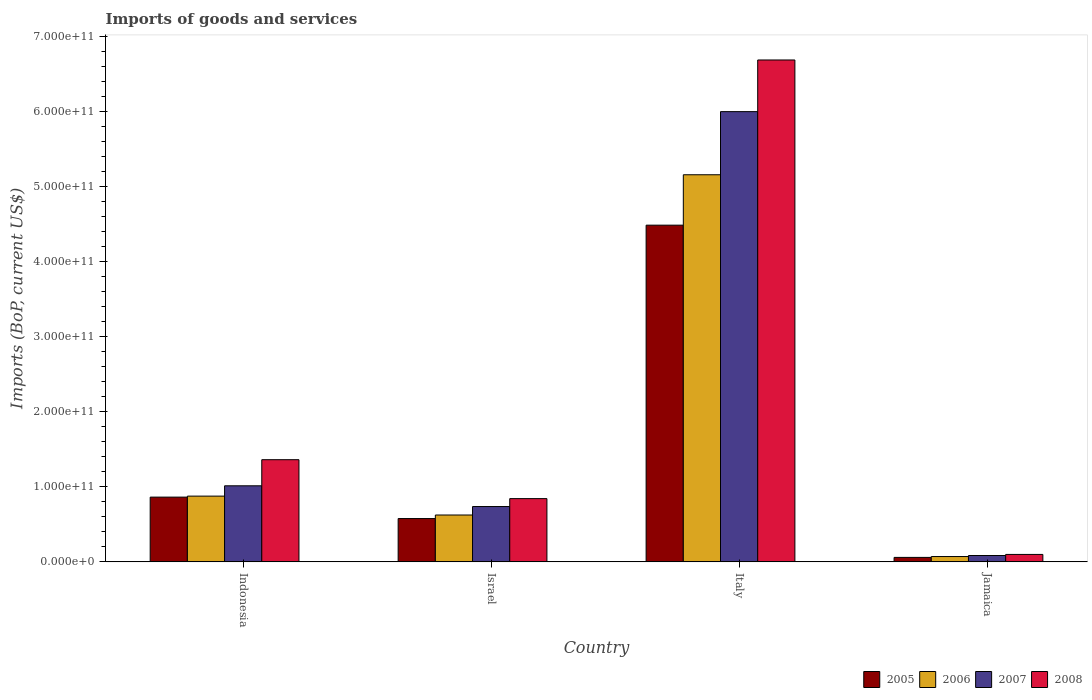How many different coloured bars are there?
Offer a terse response. 4. Are the number of bars per tick equal to the number of legend labels?
Your answer should be compact. Yes. How many bars are there on the 1st tick from the right?
Offer a terse response. 4. What is the label of the 4th group of bars from the left?
Ensure brevity in your answer.  Jamaica. In how many cases, is the number of bars for a given country not equal to the number of legend labels?
Make the answer very short. 0. What is the amount spent on imports in 2006 in Italy?
Offer a very short reply. 5.16e+11. Across all countries, what is the maximum amount spent on imports in 2005?
Give a very brief answer. 4.49e+11. Across all countries, what is the minimum amount spent on imports in 2007?
Keep it short and to the point. 8.49e+09. In which country was the amount spent on imports in 2005 maximum?
Keep it short and to the point. Italy. In which country was the amount spent on imports in 2007 minimum?
Offer a terse response. Jamaica. What is the total amount spent on imports in 2006 in the graph?
Offer a very short reply. 6.73e+11. What is the difference between the amount spent on imports in 2006 in Israel and that in Jamaica?
Provide a short and direct response. 5.53e+1. What is the difference between the amount spent on imports in 2008 in Israel and the amount spent on imports in 2006 in Jamaica?
Keep it short and to the point. 7.72e+1. What is the average amount spent on imports in 2006 per country?
Keep it short and to the point. 1.68e+11. What is the difference between the amount spent on imports of/in 2005 and amount spent on imports of/in 2006 in Jamaica?
Provide a short and direct response. -1.13e+09. In how many countries, is the amount spent on imports in 2008 greater than 620000000000 US$?
Your response must be concise. 1. What is the ratio of the amount spent on imports in 2008 in Indonesia to that in Jamaica?
Make the answer very short. 13.73. Is the amount spent on imports in 2006 in Indonesia less than that in Italy?
Ensure brevity in your answer.  Yes. What is the difference between the highest and the second highest amount spent on imports in 2006?
Your answer should be compact. 4.53e+11. What is the difference between the highest and the lowest amount spent on imports in 2005?
Make the answer very short. 4.43e+11. In how many countries, is the amount spent on imports in 2005 greater than the average amount spent on imports in 2005 taken over all countries?
Make the answer very short. 1. Is the sum of the amount spent on imports in 2005 in Indonesia and Italy greater than the maximum amount spent on imports in 2007 across all countries?
Ensure brevity in your answer.  No. How many bars are there?
Offer a very short reply. 16. How many countries are there in the graph?
Your answer should be compact. 4. What is the difference between two consecutive major ticks on the Y-axis?
Make the answer very short. 1.00e+11. Are the values on the major ticks of Y-axis written in scientific E-notation?
Make the answer very short. Yes. Where does the legend appear in the graph?
Your answer should be very brief. Bottom right. How many legend labels are there?
Your answer should be very brief. 4. How are the legend labels stacked?
Your answer should be very brief. Horizontal. What is the title of the graph?
Keep it short and to the point. Imports of goods and services. What is the label or title of the Y-axis?
Provide a short and direct response. Imports (BoP, current US$). What is the Imports (BoP, current US$) of 2005 in Indonesia?
Ensure brevity in your answer.  8.63e+1. What is the Imports (BoP, current US$) of 2006 in Indonesia?
Keep it short and to the point. 8.76e+1. What is the Imports (BoP, current US$) of 2007 in Indonesia?
Your response must be concise. 1.01e+11. What is the Imports (BoP, current US$) of 2008 in Indonesia?
Offer a very short reply. 1.36e+11. What is the Imports (BoP, current US$) in 2005 in Israel?
Provide a succinct answer. 5.77e+1. What is the Imports (BoP, current US$) in 2006 in Israel?
Provide a short and direct response. 6.24e+1. What is the Imports (BoP, current US$) in 2007 in Israel?
Your response must be concise. 7.37e+1. What is the Imports (BoP, current US$) of 2008 in Israel?
Give a very brief answer. 8.43e+1. What is the Imports (BoP, current US$) in 2005 in Italy?
Give a very brief answer. 4.49e+11. What is the Imports (BoP, current US$) of 2006 in Italy?
Your answer should be very brief. 5.16e+11. What is the Imports (BoP, current US$) of 2007 in Italy?
Keep it short and to the point. 6.00e+11. What is the Imports (BoP, current US$) of 2008 in Italy?
Make the answer very short. 6.69e+11. What is the Imports (BoP, current US$) in 2005 in Jamaica?
Make the answer very short. 5.97e+09. What is the Imports (BoP, current US$) of 2006 in Jamaica?
Provide a short and direct response. 7.10e+09. What is the Imports (BoP, current US$) in 2007 in Jamaica?
Your answer should be very brief. 8.49e+09. What is the Imports (BoP, current US$) in 2008 in Jamaica?
Keep it short and to the point. 9.91e+09. Across all countries, what is the maximum Imports (BoP, current US$) in 2005?
Provide a short and direct response. 4.49e+11. Across all countries, what is the maximum Imports (BoP, current US$) of 2006?
Your answer should be compact. 5.16e+11. Across all countries, what is the maximum Imports (BoP, current US$) in 2007?
Give a very brief answer. 6.00e+11. Across all countries, what is the maximum Imports (BoP, current US$) in 2008?
Keep it short and to the point. 6.69e+11. Across all countries, what is the minimum Imports (BoP, current US$) of 2005?
Keep it short and to the point. 5.97e+09. Across all countries, what is the minimum Imports (BoP, current US$) in 2006?
Keep it short and to the point. 7.10e+09. Across all countries, what is the minimum Imports (BoP, current US$) of 2007?
Keep it short and to the point. 8.49e+09. Across all countries, what is the minimum Imports (BoP, current US$) in 2008?
Provide a short and direct response. 9.91e+09. What is the total Imports (BoP, current US$) of 2005 in the graph?
Your response must be concise. 5.99e+11. What is the total Imports (BoP, current US$) of 2006 in the graph?
Ensure brevity in your answer.  6.73e+11. What is the total Imports (BoP, current US$) in 2007 in the graph?
Your answer should be very brief. 7.83e+11. What is the total Imports (BoP, current US$) of 2008 in the graph?
Offer a terse response. 8.99e+11. What is the difference between the Imports (BoP, current US$) in 2005 in Indonesia and that in Israel?
Keep it short and to the point. 2.86e+1. What is the difference between the Imports (BoP, current US$) of 2006 in Indonesia and that in Israel?
Your response must be concise. 2.52e+1. What is the difference between the Imports (BoP, current US$) in 2007 in Indonesia and that in Israel?
Ensure brevity in your answer.  2.76e+1. What is the difference between the Imports (BoP, current US$) of 2008 in Indonesia and that in Israel?
Your answer should be compact. 5.19e+1. What is the difference between the Imports (BoP, current US$) in 2005 in Indonesia and that in Italy?
Keep it short and to the point. -3.62e+11. What is the difference between the Imports (BoP, current US$) of 2006 in Indonesia and that in Italy?
Ensure brevity in your answer.  -4.28e+11. What is the difference between the Imports (BoP, current US$) in 2007 in Indonesia and that in Italy?
Your answer should be very brief. -4.98e+11. What is the difference between the Imports (BoP, current US$) in 2008 in Indonesia and that in Italy?
Your answer should be compact. -5.33e+11. What is the difference between the Imports (BoP, current US$) of 2005 in Indonesia and that in Jamaica?
Offer a terse response. 8.03e+1. What is the difference between the Imports (BoP, current US$) in 2006 in Indonesia and that in Jamaica?
Ensure brevity in your answer.  8.05e+1. What is the difference between the Imports (BoP, current US$) in 2007 in Indonesia and that in Jamaica?
Offer a terse response. 9.29e+1. What is the difference between the Imports (BoP, current US$) of 2008 in Indonesia and that in Jamaica?
Your answer should be compact. 1.26e+11. What is the difference between the Imports (BoP, current US$) of 2005 in Israel and that in Italy?
Keep it short and to the point. -3.91e+11. What is the difference between the Imports (BoP, current US$) in 2006 in Israel and that in Italy?
Make the answer very short. -4.53e+11. What is the difference between the Imports (BoP, current US$) in 2007 in Israel and that in Italy?
Your answer should be compact. -5.26e+11. What is the difference between the Imports (BoP, current US$) in 2008 in Israel and that in Italy?
Offer a terse response. -5.84e+11. What is the difference between the Imports (BoP, current US$) in 2005 in Israel and that in Jamaica?
Offer a terse response. 5.17e+1. What is the difference between the Imports (BoP, current US$) of 2006 in Israel and that in Jamaica?
Give a very brief answer. 5.53e+1. What is the difference between the Imports (BoP, current US$) of 2007 in Israel and that in Jamaica?
Ensure brevity in your answer.  6.52e+1. What is the difference between the Imports (BoP, current US$) in 2008 in Israel and that in Jamaica?
Provide a short and direct response. 7.44e+1. What is the difference between the Imports (BoP, current US$) of 2005 in Italy and that in Jamaica?
Your answer should be compact. 4.43e+11. What is the difference between the Imports (BoP, current US$) in 2006 in Italy and that in Jamaica?
Keep it short and to the point. 5.09e+11. What is the difference between the Imports (BoP, current US$) in 2007 in Italy and that in Jamaica?
Your response must be concise. 5.91e+11. What is the difference between the Imports (BoP, current US$) in 2008 in Italy and that in Jamaica?
Offer a very short reply. 6.59e+11. What is the difference between the Imports (BoP, current US$) of 2005 in Indonesia and the Imports (BoP, current US$) of 2006 in Israel?
Keep it short and to the point. 2.38e+1. What is the difference between the Imports (BoP, current US$) of 2005 in Indonesia and the Imports (BoP, current US$) of 2007 in Israel?
Offer a very short reply. 1.26e+1. What is the difference between the Imports (BoP, current US$) of 2005 in Indonesia and the Imports (BoP, current US$) of 2008 in Israel?
Provide a short and direct response. 1.98e+09. What is the difference between the Imports (BoP, current US$) of 2006 in Indonesia and the Imports (BoP, current US$) of 2007 in Israel?
Give a very brief answer. 1.39e+1. What is the difference between the Imports (BoP, current US$) of 2006 in Indonesia and the Imports (BoP, current US$) of 2008 in Israel?
Your answer should be compact. 3.33e+09. What is the difference between the Imports (BoP, current US$) of 2007 in Indonesia and the Imports (BoP, current US$) of 2008 in Israel?
Your answer should be compact. 1.71e+1. What is the difference between the Imports (BoP, current US$) in 2005 in Indonesia and the Imports (BoP, current US$) in 2006 in Italy?
Provide a short and direct response. -4.29e+11. What is the difference between the Imports (BoP, current US$) in 2005 in Indonesia and the Imports (BoP, current US$) in 2007 in Italy?
Make the answer very short. -5.14e+11. What is the difference between the Imports (BoP, current US$) of 2005 in Indonesia and the Imports (BoP, current US$) of 2008 in Italy?
Provide a short and direct response. -5.82e+11. What is the difference between the Imports (BoP, current US$) in 2006 in Indonesia and the Imports (BoP, current US$) in 2007 in Italy?
Give a very brief answer. -5.12e+11. What is the difference between the Imports (BoP, current US$) of 2006 in Indonesia and the Imports (BoP, current US$) of 2008 in Italy?
Make the answer very short. -5.81e+11. What is the difference between the Imports (BoP, current US$) of 2007 in Indonesia and the Imports (BoP, current US$) of 2008 in Italy?
Your response must be concise. -5.67e+11. What is the difference between the Imports (BoP, current US$) of 2005 in Indonesia and the Imports (BoP, current US$) of 2006 in Jamaica?
Your answer should be compact. 7.92e+1. What is the difference between the Imports (BoP, current US$) of 2005 in Indonesia and the Imports (BoP, current US$) of 2007 in Jamaica?
Provide a short and direct response. 7.78e+1. What is the difference between the Imports (BoP, current US$) in 2005 in Indonesia and the Imports (BoP, current US$) in 2008 in Jamaica?
Your response must be concise. 7.64e+1. What is the difference between the Imports (BoP, current US$) in 2006 in Indonesia and the Imports (BoP, current US$) in 2007 in Jamaica?
Make the answer very short. 7.91e+1. What is the difference between the Imports (BoP, current US$) of 2006 in Indonesia and the Imports (BoP, current US$) of 2008 in Jamaica?
Provide a short and direct response. 7.77e+1. What is the difference between the Imports (BoP, current US$) of 2007 in Indonesia and the Imports (BoP, current US$) of 2008 in Jamaica?
Give a very brief answer. 9.14e+1. What is the difference between the Imports (BoP, current US$) of 2005 in Israel and the Imports (BoP, current US$) of 2006 in Italy?
Ensure brevity in your answer.  -4.58e+11. What is the difference between the Imports (BoP, current US$) of 2005 in Israel and the Imports (BoP, current US$) of 2007 in Italy?
Your response must be concise. -5.42e+11. What is the difference between the Imports (BoP, current US$) in 2005 in Israel and the Imports (BoP, current US$) in 2008 in Italy?
Offer a terse response. -6.11e+11. What is the difference between the Imports (BoP, current US$) of 2006 in Israel and the Imports (BoP, current US$) of 2007 in Italy?
Provide a succinct answer. -5.37e+11. What is the difference between the Imports (BoP, current US$) in 2006 in Israel and the Imports (BoP, current US$) in 2008 in Italy?
Ensure brevity in your answer.  -6.06e+11. What is the difference between the Imports (BoP, current US$) of 2007 in Israel and the Imports (BoP, current US$) of 2008 in Italy?
Offer a terse response. -5.95e+11. What is the difference between the Imports (BoP, current US$) of 2005 in Israel and the Imports (BoP, current US$) of 2006 in Jamaica?
Make the answer very short. 5.06e+1. What is the difference between the Imports (BoP, current US$) in 2005 in Israel and the Imports (BoP, current US$) in 2007 in Jamaica?
Make the answer very short. 4.92e+1. What is the difference between the Imports (BoP, current US$) in 2005 in Israel and the Imports (BoP, current US$) in 2008 in Jamaica?
Give a very brief answer. 4.78e+1. What is the difference between the Imports (BoP, current US$) in 2006 in Israel and the Imports (BoP, current US$) in 2007 in Jamaica?
Offer a terse response. 5.40e+1. What is the difference between the Imports (BoP, current US$) in 2006 in Israel and the Imports (BoP, current US$) in 2008 in Jamaica?
Offer a very short reply. 5.25e+1. What is the difference between the Imports (BoP, current US$) in 2007 in Israel and the Imports (BoP, current US$) in 2008 in Jamaica?
Offer a very short reply. 6.38e+1. What is the difference between the Imports (BoP, current US$) of 2005 in Italy and the Imports (BoP, current US$) of 2006 in Jamaica?
Ensure brevity in your answer.  4.41e+11. What is the difference between the Imports (BoP, current US$) of 2005 in Italy and the Imports (BoP, current US$) of 2007 in Jamaica?
Offer a terse response. 4.40e+11. What is the difference between the Imports (BoP, current US$) of 2005 in Italy and the Imports (BoP, current US$) of 2008 in Jamaica?
Offer a terse response. 4.39e+11. What is the difference between the Imports (BoP, current US$) of 2006 in Italy and the Imports (BoP, current US$) of 2007 in Jamaica?
Make the answer very short. 5.07e+11. What is the difference between the Imports (BoP, current US$) of 2006 in Italy and the Imports (BoP, current US$) of 2008 in Jamaica?
Provide a succinct answer. 5.06e+11. What is the difference between the Imports (BoP, current US$) in 2007 in Italy and the Imports (BoP, current US$) in 2008 in Jamaica?
Your response must be concise. 5.90e+11. What is the average Imports (BoP, current US$) in 2005 per country?
Your answer should be compact. 1.50e+11. What is the average Imports (BoP, current US$) in 2006 per country?
Ensure brevity in your answer.  1.68e+11. What is the average Imports (BoP, current US$) in 2007 per country?
Offer a very short reply. 1.96e+11. What is the average Imports (BoP, current US$) in 2008 per country?
Ensure brevity in your answer.  2.25e+11. What is the difference between the Imports (BoP, current US$) in 2005 and Imports (BoP, current US$) in 2006 in Indonesia?
Offer a very short reply. -1.35e+09. What is the difference between the Imports (BoP, current US$) in 2005 and Imports (BoP, current US$) in 2007 in Indonesia?
Provide a short and direct response. -1.51e+1. What is the difference between the Imports (BoP, current US$) of 2005 and Imports (BoP, current US$) of 2008 in Indonesia?
Offer a terse response. -4.99e+1. What is the difference between the Imports (BoP, current US$) of 2006 and Imports (BoP, current US$) of 2007 in Indonesia?
Make the answer very short. -1.37e+1. What is the difference between the Imports (BoP, current US$) in 2006 and Imports (BoP, current US$) in 2008 in Indonesia?
Keep it short and to the point. -4.85e+1. What is the difference between the Imports (BoP, current US$) of 2007 and Imports (BoP, current US$) of 2008 in Indonesia?
Offer a terse response. -3.48e+1. What is the difference between the Imports (BoP, current US$) of 2005 and Imports (BoP, current US$) of 2006 in Israel?
Give a very brief answer. -4.73e+09. What is the difference between the Imports (BoP, current US$) of 2005 and Imports (BoP, current US$) of 2007 in Israel?
Your answer should be very brief. -1.60e+1. What is the difference between the Imports (BoP, current US$) in 2005 and Imports (BoP, current US$) in 2008 in Israel?
Offer a very short reply. -2.66e+1. What is the difference between the Imports (BoP, current US$) in 2006 and Imports (BoP, current US$) in 2007 in Israel?
Provide a short and direct response. -1.13e+1. What is the difference between the Imports (BoP, current US$) of 2006 and Imports (BoP, current US$) of 2008 in Israel?
Offer a terse response. -2.18e+1. What is the difference between the Imports (BoP, current US$) in 2007 and Imports (BoP, current US$) in 2008 in Israel?
Your answer should be compact. -1.06e+1. What is the difference between the Imports (BoP, current US$) of 2005 and Imports (BoP, current US$) of 2006 in Italy?
Your answer should be very brief. -6.72e+1. What is the difference between the Imports (BoP, current US$) in 2005 and Imports (BoP, current US$) in 2007 in Italy?
Provide a short and direct response. -1.51e+11. What is the difference between the Imports (BoP, current US$) in 2005 and Imports (BoP, current US$) in 2008 in Italy?
Your response must be concise. -2.20e+11. What is the difference between the Imports (BoP, current US$) of 2006 and Imports (BoP, current US$) of 2007 in Italy?
Offer a very short reply. -8.41e+1. What is the difference between the Imports (BoP, current US$) in 2006 and Imports (BoP, current US$) in 2008 in Italy?
Offer a very short reply. -1.53e+11. What is the difference between the Imports (BoP, current US$) in 2007 and Imports (BoP, current US$) in 2008 in Italy?
Ensure brevity in your answer.  -6.88e+1. What is the difference between the Imports (BoP, current US$) in 2005 and Imports (BoP, current US$) in 2006 in Jamaica?
Give a very brief answer. -1.13e+09. What is the difference between the Imports (BoP, current US$) of 2005 and Imports (BoP, current US$) of 2007 in Jamaica?
Your response must be concise. -2.52e+09. What is the difference between the Imports (BoP, current US$) of 2005 and Imports (BoP, current US$) of 2008 in Jamaica?
Provide a succinct answer. -3.95e+09. What is the difference between the Imports (BoP, current US$) in 2006 and Imports (BoP, current US$) in 2007 in Jamaica?
Ensure brevity in your answer.  -1.39e+09. What is the difference between the Imports (BoP, current US$) of 2006 and Imports (BoP, current US$) of 2008 in Jamaica?
Your answer should be very brief. -2.82e+09. What is the difference between the Imports (BoP, current US$) in 2007 and Imports (BoP, current US$) in 2008 in Jamaica?
Make the answer very short. -1.43e+09. What is the ratio of the Imports (BoP, current US$) in 2005 in Indonesia to that in Israel?
Make the answer very short. 1.49. What is the ratio of the Imports (BoP, current US$) in 2006 in Indonesia to that in Israel?
Ensure brevity in your answer.  1.4. What is the ratio of the Imports (BoP, current US$) in 2007 in Indonesia to that in Israel?
Offer a very short reply. 1.37. What is the ratio of the Imports (BoP, current US$) in 2008 in Indonesia to that in Israel?
Make the answer very short. 1.62. What is the ratio of the Imports (BoP, current US$) in 2005 in Indonesia to that in Italy?
Your answer should be very brief. 0.19. What is the ratio of the Imports (BoP, current US$) in 2006 in Indonesia to that in Italy?
Your response must be concise. 0.17. What is the ratio of the Imports (BoP, current US$) of 2007 in Indonesia to that in Italy?
Offer a terse response. 0.17. What is the ratio of the Imports (BoP, current US$) of 2008 in Indonesia to that in Italy?
Provide a succinct answer. 0.2. What is the ratio of the Imports (BoP, current US$) in 2005 in Indonesia to that in Jamaica?
Your answer should be very brief. 14.46. What is the ratio of the Imports (BoP, current US$) in 2006 in Indonesia to that in Jamaica?
Your answer should be compact. 12.34. What is the ratio of the Imports (BoP, current US$) in 2007 in Indonesia to that in Jamaica?
Ensure brevity in your answer.  11.94. What is the ratio of the Imports (BoP, current US$) of 2008 in Indonesia to that in Jamaica?
Your answer should be very brief. 13.73. What is the ratio of the Imports (BoP, current US$) in 2005 in Israel to that in Italy?
Provide a short and direct response. 0.13. What is the ratio of the Imports (BoP, current US$) in 2006 in Israel to that in Italy?
Provide a short and direct response. 0.12. What is the ratio of the Imports (BoP, current US$) of 2007 in Israel to that in Italy?
Your answer should be compact. 0.12. What is the ratio of the Imports (BoP, current US$) of 2008 in Israel to that in Italy?
Provide a succinct answer. 0.13. What is the ratio of the Imports (BoP, current US$) of 2005 in Israel to that in Jamaica?
Keep it short and to the point. 9.67. What is the ratio of the Imports (BoP, current US$) of 2006 in Israel to that in Jamaica?
Make the answer very short. 8.8. What is the ratio of the Imports (BoP, current US$) of 2007 in Israel to that in Jamaica?
Offer a terse response. 8.69. What is the ratio of the Imports (BoP, current US$) of 2008 in Israel to that in Jamaica?
Provide a succinct answer. 8.5. What is the ratio of the Imports (BoP, current US$) of 2005 in Italy to that in Jamaica?
Give a very brief answer. 75.17. What is the ratio of the Imports (BoP, current US$) of 2006 in Italy to that in Jamaica?
Offer a terse response. 72.66. What is the ratio of the Imports (BoP, current US$) in 2007 in Italy to that in Jamaica?
Your answer should be compact. 70.69. What is the ratio of the Imports (BoP, current US$) in 2008 in Italy to that in Jamaica?
Offer a very short reply. 67.45. What is the difference between the highest and the second highest Imports (BoP, current US$) of 2005?
Offer a very short reply. 3.62e+11. What is the difference between the highest and the second highest Imports (BoP, current US$) of 2006?
Your answer should be compact. 4.28e+11. What is the difference between the highest and the second highest Imports (BoP, current US$) in 2007?
Provide a short and direct response. 4.98e+11. What is the difference between the highest and the second highest Imports (BoP, current US$) of 2008?
Provide a succinct answer. 5.33e+11. What is the difference between the highest and the lowest Imports (BoP, current US$) of 2005?
Offer a terse response. 4.43e+11. What is the difference between the highest and the lowest Imports (BoP, current US$) of 2006?
Offer a very short reply. 5.09e+11. What is the difference between the highest and the lowest Imports (BoP, current US$) in 2007?
Your answer should be very brief. 5.91e+11. What is the difference between the highest and the lowest Imports (BoP, current US$) in 2008?
Provide a succinct answer. 6.59e+11. 